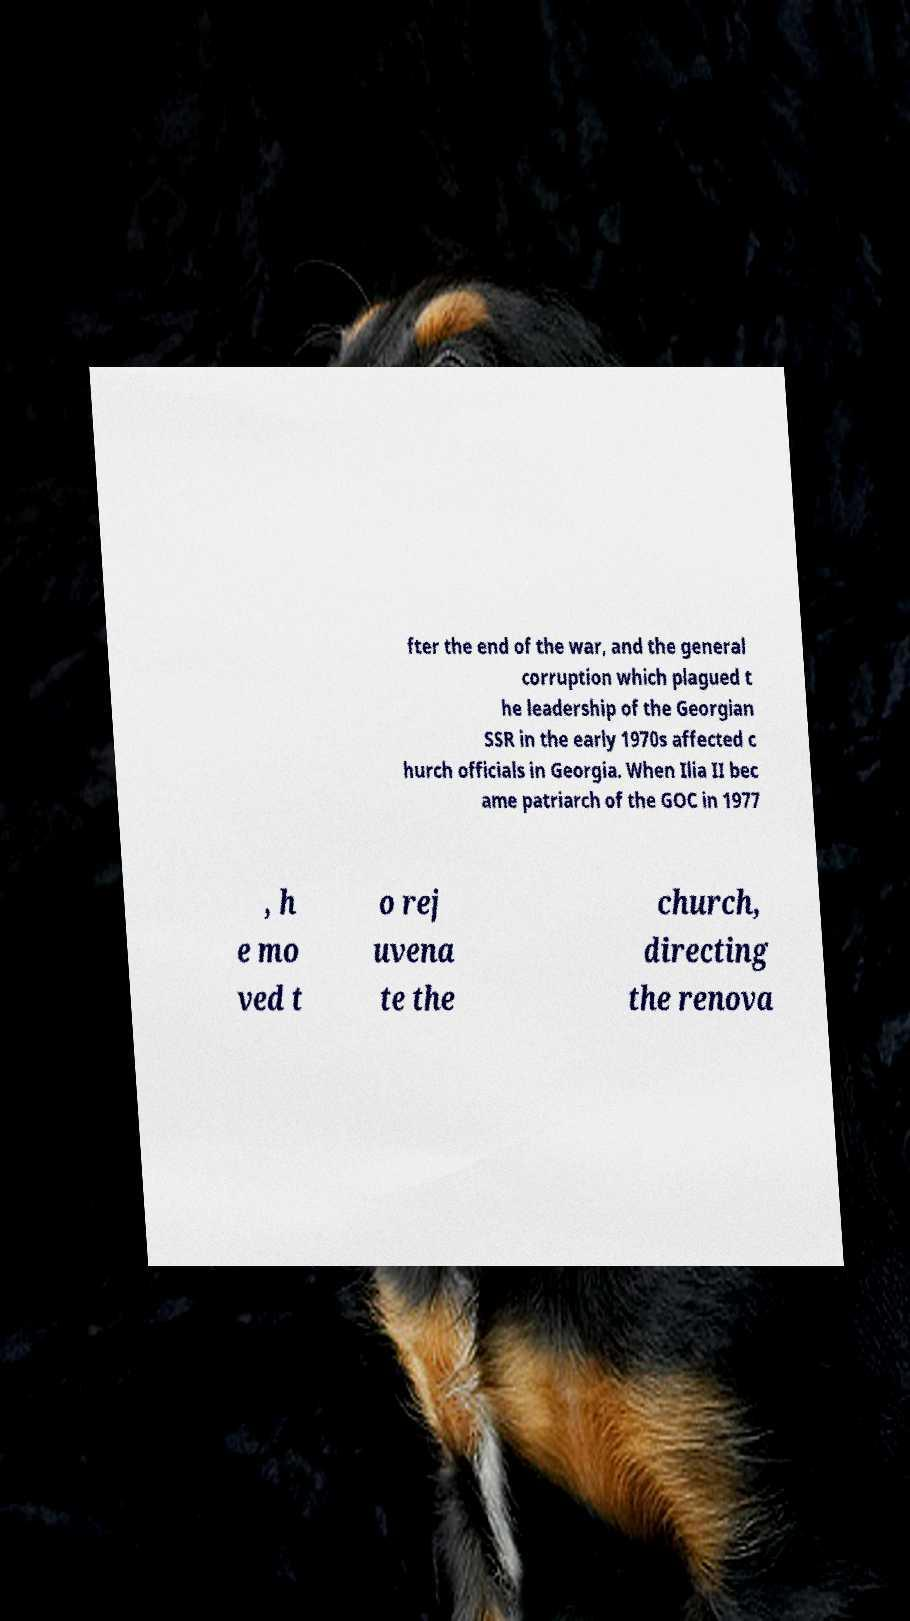For documentation purposes, I need the text within this image transcribed. Could you provide that? fter the end of the war, and the general corruption which plagued t he leadership of the Georgian SSR in the early 1970s affected c hurch officials in Georgia. When Ilia II bec ame patriarch of the GOC in 1977 , h e mo ved t o rej uvena te the church, directing the renova 